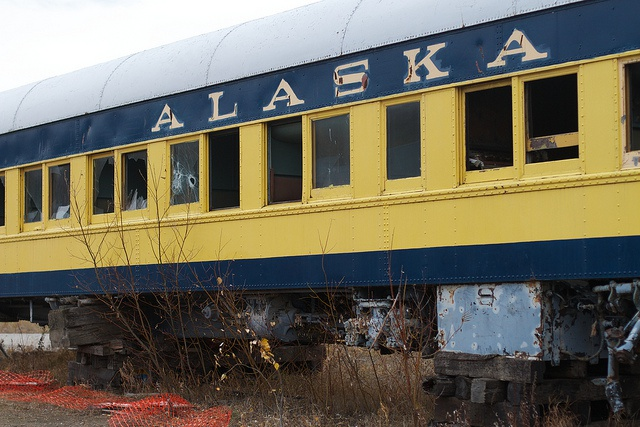Describe the objects in this image and their specific colors. I can see a train in black, white, tan, navy, and lightgray tones in this image. 